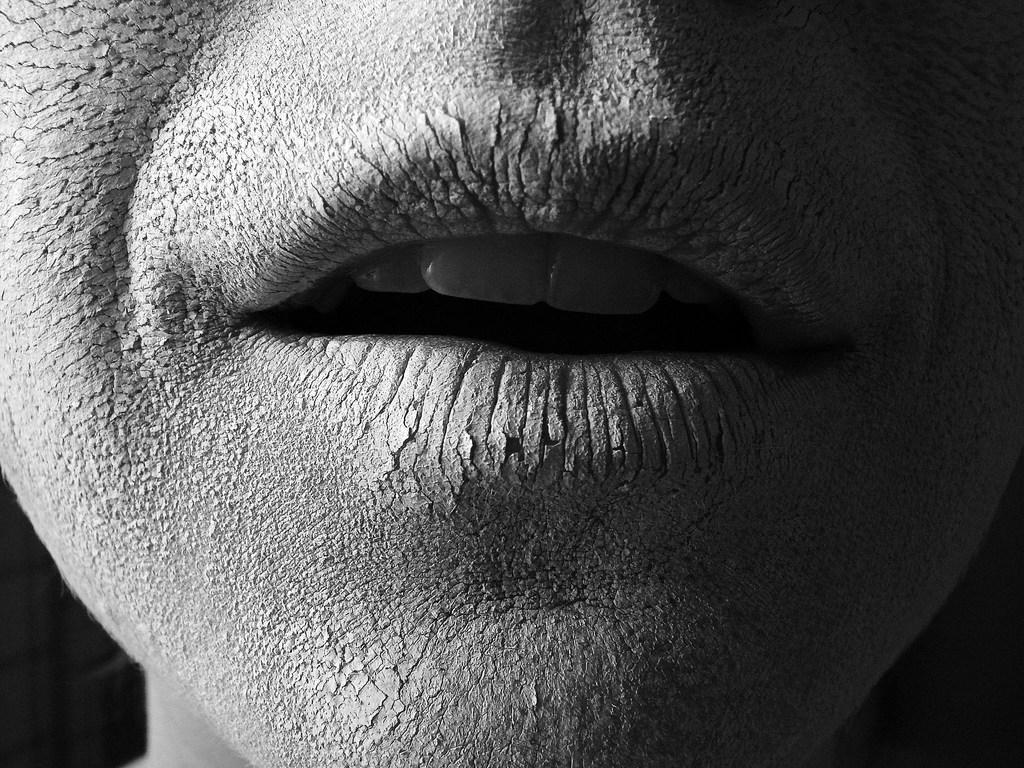What part of a person's face is visible in the image? There is a person's mouth in the image. What can be seen inside the person's mouth? The person's teeth are visible in the image. What type of worm can be seen crawling on the person's teeth in the image? There is no worm present in the image; only the person's mouth and teeth are visible. 